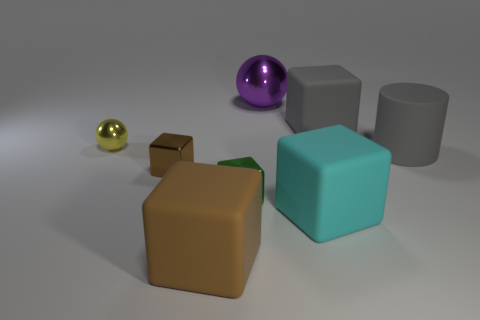Subtract 1 blocks. How many blocks are left? 4 Subtract all purple blocks. Subtract all purple cylinders. How many blocks are left? 5 Add 1 big cyan things. How many objects exist? 9 Subtract all blocks. How many objects are left? 3 Add 5 small green shiny cubes. How many small green shiny cubes are left? 6 Add 6 tiny red spheres. How many tiny red spheres exist? 6 Subtract 0 blue balls. How many objects are left? 8 Subtract all large spheres. Subtract all large brown cubes. How many objects are left? 6 